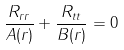Convert formula to latex. <formula><loc_0><loc_0><loc_500><loc_500>\frac { R _ { r r } } { A ( r ) } + \frac { R _ { t t } } { B ( r ) } = 0</formula> 